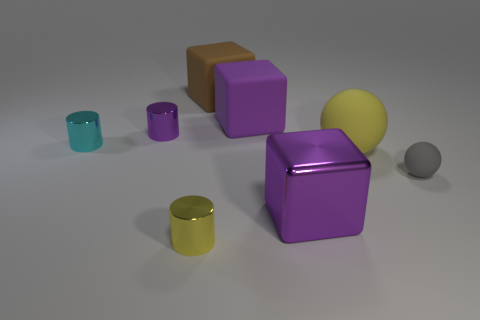Is the shape of the gray rubber object the same as the brown thing?
Ensure brevity in your answer.  No. There is a thing on the right side of the big yellow sphere; does it have the same shape as the big yellow rubber thing?
Provide a short and direct response. Yes. How many gray spheres are the same size as the gray rubber thing?
Offer a very short reply. 0. What number of purple objects are right of the thing that is on the right side of the yellow rubber object?
Ensure brevity in your answer.  0. Is the large purple object that is in front of the purple rubber cube made of the same material as the big brown object?
Your answer should be very brief. No. Are the yellow thing that is behind the gray matte thing and the tiny thing that is right of the big brown matte block made of the same material?
Keep it short and to the point. Yes. Is the number of small cyan metal cylinders that are right of the tiny purple thing greater than the number of cyan rubber cubes?
Ensure brevity in your answer.  No. There is a small metal object that is on the left side of the purple shiny object that is behind the gray ball; what color is it?
Your answer should be very brief. Cyan. What shape is the brown matte thing that is the same size as the purple shiny block?
Your response must be concise. Cube. What is the shape of the small metal thing that is the same color as the large metallic object?
Provide a short and direct response. Cylinder. 